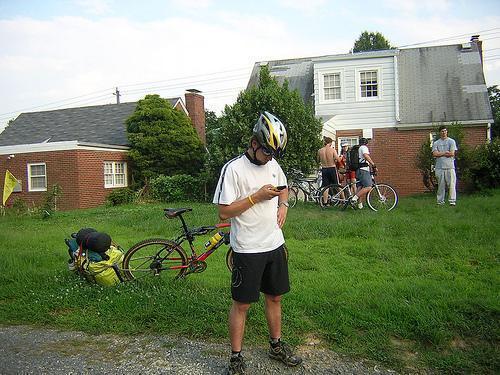How many bicycles are there?
Give a very brief answer. 3. 